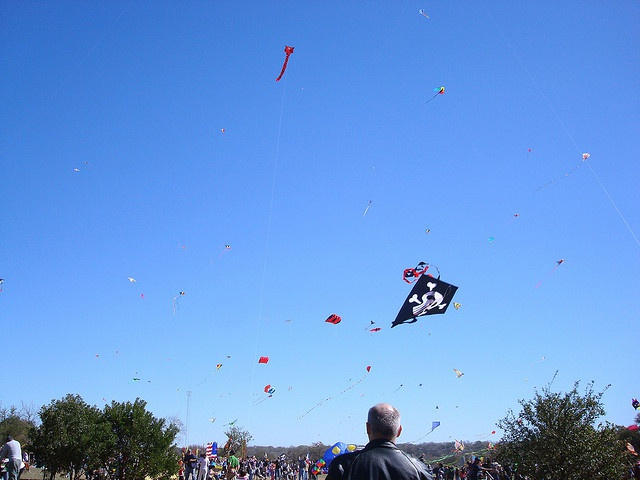Describe the objects in this image and their specific colors. I can see kite in blue, lightblue, and black tones, people in blue, black, gray, and darkgray tones, kite in blue, black, navy, white, and gray tones, people in blue, black, lavender, navy, and gray tones, and people in blue, black, navy, and gray tones in this image. 